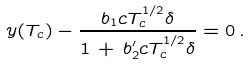Convert formula to latex. <formula><loc_0><loc_0><loc_500><loc_500>y ( T _ { c } ) - \frac { b _ { 1 } c T _ { c } ^ { 1 / 2 } \delta } { 1 \, + \, b _ { 2 } ^ { \prime } c T _ { c } ^ { 1 / 2 } \delta } = 0 \, .</formula> 